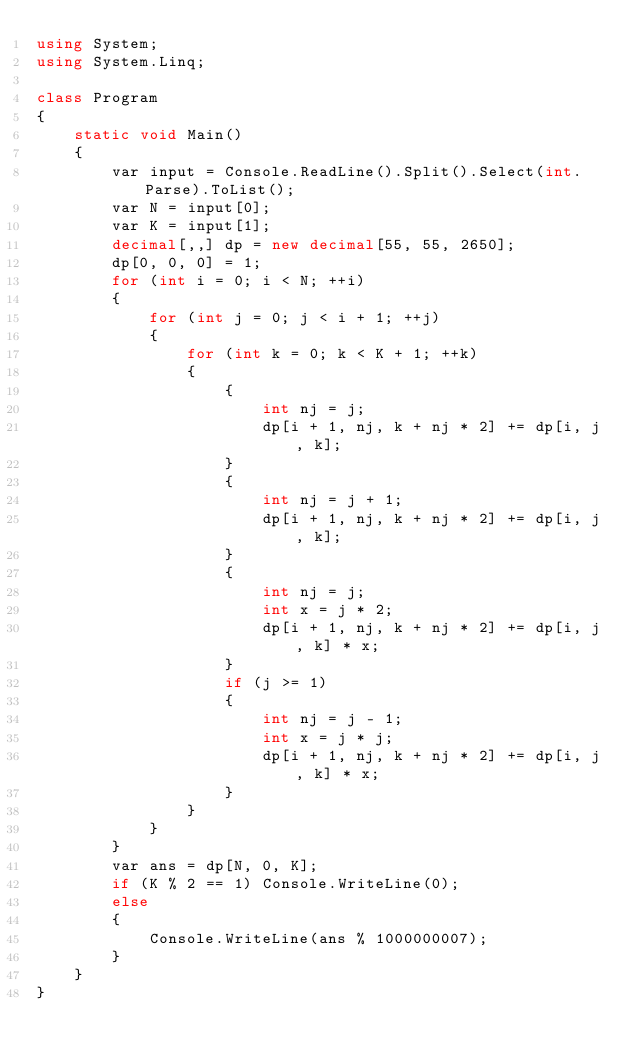<code> <loc_0><loc_0><loc_500><loc_500><_C#_>using System;
using System.Linq;

class Program
{
    static void Main()
    {
        var input = Console.ReadLine().Split().Select(int.Parse).ToList();
        var N = input[0];
        var K = input[1];
        decimal[,,] dp = new decimal[55, 55, 2650];
        dp[0, 0, 0] = 1;
        for (int i = 0; i < N; ++i)
        {
            for (int j = 0; j < i + 1; ++j)
            {
                for (int k = 0; k < K + 1; ++k)
                {
                    {
                        int nj = j;
                        dp[i + 1, nj, k + nj * 2] += dp[i, j, k];
                    }
                    {
                        int nj = j + 1;
                        dp[i + 1, nj, k + nj * 2] += dp[i, j, k];
                    }
                    {
                        int nj = j;
                        int x = j * 2;
                        dp[i + 1, nj, k + nj * 2] += dp[i, j, k] * x;
                    }
                    if (j >= 1)
                    {
                        int nj = j - 1;
                        int x = j * j;
                        dp[i + 1, nj, k + nj * 2] += dp[i, j, k] * x;
                    }
                }
            }
        }
        var ans = dp[N, 0, K];
        if (K % 2 == 1) Console.WriteLine(0);
        else
        {
            Console.WriteLine(ans % 1000000007);
        }
    }
}


</code> 